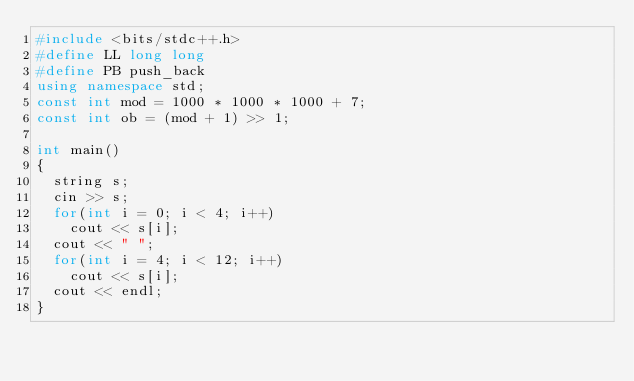Convert code to text. <code><loc_0><loc_0><loc_500><loc_500><_C++_>#include <bits/stdc++.h>
#define LL long long
#define PB push_back
using namespace std;
const int mod = 1000 * 1000 * 1000 + 7;
const int ob = (mod + 1) >> 1;
	
int main()
{
	string s;
	cin >> s;
	for(int i = 0; i < 4; i++)
		cout << s[i];
	cout << " ";
	for(int i = 4; i < 12; i++)
		cout << s[i];
	cout << endl;
}


</code> 